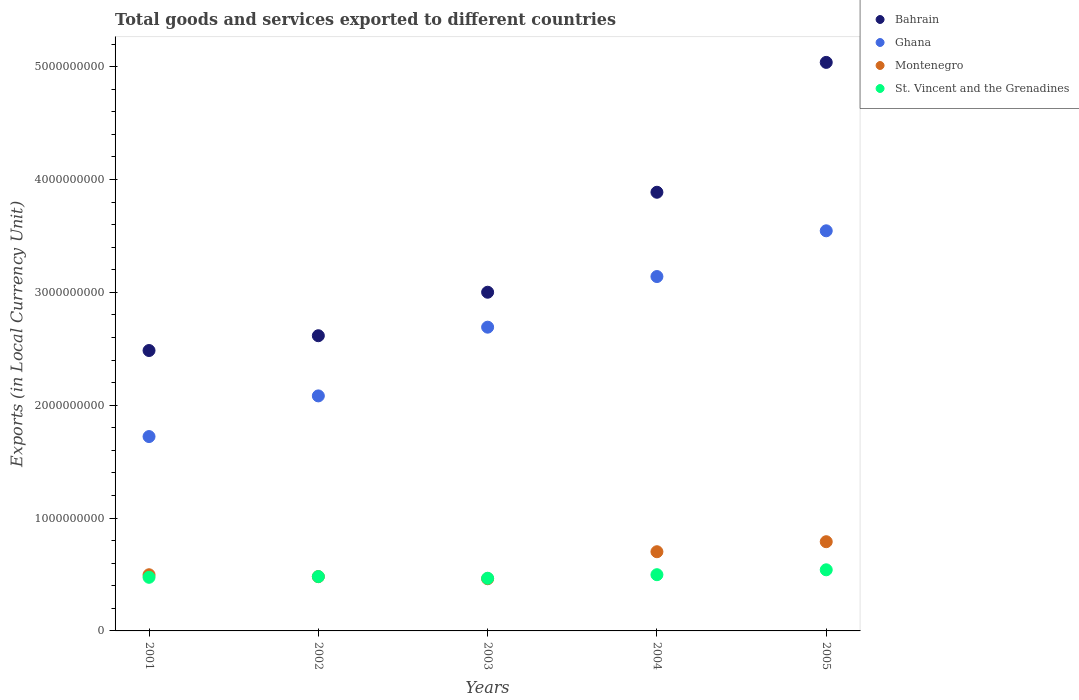Is the number of dotlines equal to the number of legend labels?
Offer a very short reply. Yes. What is the Amount of goods and services exports in St. Vincent and the Grenadines in 2004?
Make the answer very short. 4.98e+08. Across all years, what is the maximum Amount of goods and services exports in Ghana?
Your response must be concise. 3.55e+09. Across all years, what is the minimum Amount of goods and services exports in Ghana?
Keep it short and to the point. 1.72e+09. What is the total Amount of goods and services exports in Montenegro in the graph?
Keep it short and to the point. 2.93e+09. What is the difference between the Amount of goods and services exports in Ghana in 2001 and that in 2005?
Your answer should be compact. -1.82e+09. What is the difference between the Amount of goods and services exports in St. Vincent and the Grenadines in 2004 and the Amount of goods and services exports in Ghana in 2001?
Provide a short and direct response. -1.22e+09. What is the average Amount of goods and services exports in Bahrain per year?
Your answer should be very brief. 3.40e+09. In the year 2003, what is the difference between the Amount of goods and services exports in Bahrain and Amount of goods and services exports in Montenegro?
Your answer should be compact. 2.54e+09. What is the ratio of the Amount of goods and services exports in Bahrain in 2003 to that in 2005?
Make the answer very short. 0.6. Is the difference between the Amount of goods and services exports in Bahrain in 2002 and 2005 greater than the difference between the Amount of goods and services exports in Montenegro in 2002 and 2005?
Offer a terse response. No. What is the difference between the highest and the second highest Amount of goods and services exports in Ghana?
Give a very brief answer. 4.05e+08. What is the difference between the highest and the lowest Amount of goods and services exports in St. Vincent and the Grenadines?
Your answer should be compact. 7.48e+07. In how many years, is the Amount of goods and services exports in Montenegro greater than the average Amount of goods and services exports in Montenegro taken over all years?
Provide a short and direct response. 2. Does the Amount of goods and services exports in Montenegro monotonically increase over the years?
Give a very brief answer. No. What is the difference between two consecutive major ticks on the Y-axis?
Keep it short and to the point. 1.00e+09. Are the values on the major ticks of Y-axis written in scientific E-notation?
Give a very brief answer. No. Does the graph contain grids?
Your answer should be compact. No. Where does the legend appear in the graph?
Your answer should be very brief. Top right. How many legend labels are there?
Your answer should be compact. 4. How are the legend labels stacked?
Your answer should be very brief. Vertical. What is the title of the graph?
Provide a succinct answer. Total goods and services exported to different countries. Does "Tonga" appear as one of the legend labels in the graph?
Provide a succinct answer. No. What is the label or title of the X-axis?
Offer a terse response. Years. What is the label or title of the Y-axis?
Provide a short and direct response. Exports (in Local Currency Unit). What is the Exports (in Local Currency Unit) of Bahrain in 2001?
Keep it short and to the point. 2.48e+09. What is the Exports (in Local Currency Unit) of Ghana in 2001?
Offer a terse response. 1.72e+09. What is the Exports (in Local Currency Unit) in Montenegro in 2001?
Offer a terse response. 4.98e+08. What is the Exports (in Local Currency Unit) in St. Vincent and the Grenadines in 2001?
Offer a terse response. 4.75e+08. What is the Exports (in Local Currency Unit) of Bahrain in 2002?
Your response must be concise. 2.62e+09. What is the Exports (in Local Currency Unit) in Ghana in 2002?
Your response must be concise. 2.08e+09. What is the Exports (in Local Currency Unit) in Montenegro in 2002?
Your answer should be very brief. 4.81e+08. What is the Exports (in Local Currency Unit) of St. Vincent and the Grenadines in 2002?
Keep it short and to the point. 4.81e+08. What is the Exports (in Local Currency Unit) of Bahrain in 2003?
Your answer should be very brief. 3.00e+09. What is the Exports (in Local Currency Unit) in Ghana in 2003?
Your answer should be compact. 2.69e+09. What is the Exports (in Local Currency Unit) of Montenegro in 2003?
Offer a very short reply. 4.62e+08. What is the Exports (in Local Currency Unit) of St. Vincent and the Grenadines in 2003?
Your answer should be compact. 4.67e+08. What is the Exports (in Local Currency Unit) of Bahrain in 2004?
Keep it short and to the point. 3.89e+09. What is the Exports (in Local Currency Unit) in Ghana in 2004?
Offer a very short reply. 3.14e+09. What is the Exports (in Local Currency Unit) in Montenegro in 2004?
Offer a terse response. 7.02e+08. What is the Exports (in Local Currency Unit) of St. Vincent and the Grenadines in 2004?
Offer a terse response. 4.98e+08. What is the Exports (in Local Currency Unit) in Bahrain in 2005?
Your answer should be very brief. 5.04e+09. What is the Exports (in Local Currency Unit) in Ghana in 2005?
Offer a very short reply. 3.55e+09. What is the Exports (in Local Currency Unit) in Montenegro in 2005?
Keep it short and to the point. 7.90e+08. What is the Exports (in Local Currency Unit) of St. Vincent and the Grenadines in 2005?
Ensure brevity in your answer.  5.41e+08. Across all years, what is the maximum Exports (in Local Currency Unit) of Bahrain?
Give a very brief answer. 5.04e+09. Across all years, what is the maximum Exports (in Local Currency Unit) in Ghana?
Provide a succinct answer. 3.55e+09. Across all years, what is the maximum Exports (in Local Currency Unit) of Montenegro?
Offer a terse response. 7.90e+08. Across all years, what is the maximum Exports (in Local Currency Unit) in St. Vincent and the Grenadines?
Ensure brevity in your answer.  5.41e+08. Across all years, what is the minimum Exports (in Local Currency Unit) of Bahrain?
Offer a terse response. 2.48e+09. Across all years, what is the minimum Exports (in Local Currency Unit) of Ghana?
Make the answer very short. 1.72e+09. Across all years, what is the minimum Exports (in Local Currency Unit) in Montenegro?
Ensure brevity in your answer.  4.62e+08. Across all years, what is the minimum Exports (in Local Currency Unit) of St. Vincent and the Grenadines?
Make the answer very short. 4.67e+08. What is the total Exports (in Local Currency Unit) of Bahrain in the graph?
Ensure brevity in your answer.  1.70e+1. What is the total Exports (in Local Currency Unit) in Ghana in the graph?
Provide a short and direct response. 1.32e+1. What is the total Exports (in Local Currency Unit) in Montenegro in the graph?
Your answer should be very brief. 2.93e+09. What is the total Exports (in Local Currency Unit) in St. Vincent and the Grenadines in the graph?
Make the answer very short. 2.46e+09. What is the difference between the Exports (in Local Currency Unit) of Bahrain in 2001 and that in 2002?
Provide a short and direct response. -1.31e+08. What is the difference between the Exports (in Local Currency Unit) in Ghana in 2001 and that in 2002?
Give a very brief answer. -3.60e+08. What is the difference between the Exports (in Local Currency Unit) of Montenegro in 2001 and that in 2002?
Your answer should be compact. 1.67e+07. What is the difference between the Exports (in Local Currency Unit) in St. Vincent and the Grenadines in 2001 and that in 2002?
Provide a succinct answer. -6.40e+06. What is the difference between the Exports (in Local Currency Unit) in Bahrain in 2001 and that in 2003?
Offer a very short reply. -5.16e+08. What is the difference between the Exports (in Local Currency Unit) in Ghana in 2001 and that in 2003?
Ensure brevity in your answer.  -9.69e+08. What is the difference between the Exports (in Local Currency Unit) in Montenegro in 2001 and that in 2003?
Make the answer very short. 3.54e+07. What is the difference between the Exports (in Local Currency Unit) in St. Vincent and the Grenadines in 2001 and that in 2003?
Provide a succinct answer. 8.35e+06. What is the difference between the Exports (in Local Currency Unit) in Bahrain in 2001 and that in 2004?
Your answer should be compact. -1.40e+09. What is the difference between the Exports (in Local Currency Unit) of Ghana in 2001 and that in 2004?
Your response must be concise. -1.42e+09. What is the difference between the Exports (in Local Currency Unit) in Montenegro in 2001 and that in 2004?
Provide a short and direct response. -2.04e+08. What is the difference between the Exports (in Local Currency Unit) in St. Vincent and the Grenadines in 2001 and that in 2004?
Your response must be concise. -2.32e+07. What is the difference between the Exports (in Local Currency Unit) of Bahrain in 2001 and that in 2005?
Ensure brevity in your answer.  -2.55e+09. What is the difference between the Exports (in Local Currency Unit) of Ghana in 2001 and that in 2005?
Your answer should be compact. -1.82e+09. What is the difference between the Exports (in Local Currency Unit) in Montenegro in 2001 and that in 2005?
Provide a short and direct response. -2.93e+08. What is the difference between the Exports (in Local Currency Unit) of St. Vincent and the Grenadines in 2001 and that in 2005?
Ensure brevity in your answer.  -6.64e+07. What is the difference between the Exports (in Local Currency Unit) in Bahrain in 2002 and that in 2003?
Your answer should be very brief. -3.85e+08. What is the difference between the Exports (in Local Currency Unit) in Ghana in 2002 and that in 2003?
Provide a short and direct response. -6.09e+08. What is the difference between the Exports (in Local Currency Unit) in Montenegro in 2002 and that in 2003?
Give a very brief answer. 1.87e+07. What is the difference between the Exports (in Local Currency Unit) of St. Vincent and the Grenadines in 2002 and that in 2003?
Make the answer very short. 1.48e+07. What is the difference between the Exports (in Local Currency Unit) in Bahrain in 2002 and that in 2004?
Keep it short and to the point. -1.27e+09. What is the difference between the Exports (in Local Currency Unit) of Ghana in 2002 and that in 2004?
Make the answer very short. -1.06e+09. What is the difference between the Exports (in Local Currency Unit) in Montenegro in 2002 and that in 2004?
Offer a terse response. -2.21e+08. What is the difference between the Exports (in Local Currency Unit) of St. Vincent and the Grenadines in 2002 and that in 2004?
Keep it short and to the point. -1.68e+07. What is the difference between the Exports (in Local Currency Unit) of Bahrain in 2002 and that in 2005?
Your answer should be very brief. -2.42e+09. What is the difference between the Exports (in Local Currency Unit) of Ghana in 2002 and that in 2005?
Give a very brief answer. -1.46e+09. What is the difference between the Exports (in Local Currency Unit) in Montenegro in 2002 and that in 2005?
Ensure brevity in your answer.  -3.09e+08. What is the difference between the Exports (in Local Currency Unit) of St. Vincent and the Grenadines in 2002 and that in 2005?
Make the answer very short. -6.00e+07. What is the difference between the Exports (in Local Currency Unit) of Bahrain in 2003 and that in 2004?
Provide a succinct answer. -8.86e+08. What is the difference between the Exports (in Local Currency Unit) in Ghana in 2003 and that in 2004?
Your response must be concise. -4.49e+08. What is the difference between the Exports (in Local Currency Unit) in Montenegro in 2003 and that in 2004?
Make the answer very short. -2.39e+08. What is the difference between the Exports (in Local Currency Unit) in St. Vincent and the Grenadines in 2003 and that in 2004?
Your response must be concise. -3.15e+07. What is the difference between the Exports (in Local Currency Unit) of Bahrain in 2003 and that in 2005?
Offer a very short reply. -2.04e+09. What is the difference between the Exports (in Local Currency Unit) in Ghana in 2003 and that in 2005?
Your response must be concise. -8.54e+08. What is the difference between the Exports (in Local Currency Unit) in Montenegro in 2003 and that in 2005?
Your response must be concise. -3.28e+08. What is the difference between the Exports (in Local Currency Unit) of St. Vincent and the Grenadines in 2003 and that in 2005?
Give a very brief answer. -7.48e+07. What is the difference between the Exports (in Local Currency Unit) in Bahrain in 2004 and that in 2005?
Give a very brief answer. -1.15e+09. What is the difference between the Exports (in Local Currency Unit) of Ghana in 2004 and that in 2005?
Offer a terse response. -4.05e+08. What is the difference between the Exports (in Local Currency Unit) in Montenegro in 2004 and that in 2005?
Keep it short and to the point. -8.87e+07. What is the difference between the Exports (in Local Currency Unit) of St. Vincent and the Grenadines in 2004 and that in 2005?
Give a very brief answer. -4.33e+07. What is the difference between the Exports (in Local Currency Unit) of Bahrain in 2001 and the Exports (in Local Currency Unit) of Ghana in 2002?
Your response must be concise. 4.02e+08. What is the difference between the Exports (in Local Currency Unit) of Bahrain in 2001 and the Exports (in Local Currency Unit) of Montenegro in 2002?
Provide a short and direct response. 2.00e+09. What is the difference between the Exports (in Local Currency Unit) in Bahrain in 2001 and the Exports (in Local Currency Unit) in St. Vincent and the Grenadines in 2002?
Make the answer very short. 2.00e+09. What is the difference between the Exports (in Local Currency Unit) in Ghana in 2001 and the Exports (in Local Currency Unit) in Montenegro in 2002?
Offer a very short reply. 1.24e+09. What is the difference between the Exports (in Local Currency Unit) of Ghana in 2001 and the Exports (in Local Currency Unit) of St. Vincent and the Grenadines in 2002?
Provide a succinct answer. 1.24e+09. What is the difference between the Exports (in Local Currency Unit) of Montenegro in 2001 and the Exports (in Local Currency Unit) of St. Vincent and the Grenadines in 2002?
Keep it short and to the point. 1.62e+07. What is the difference between the Exports (in Local Currency Unit) of Bahrain in 2001 and the Exports (in Local Currency Unit) of Ghana in 2003?
Offer a terse response. -2.07e+08. What is the difference between the Exports (in Local Currency Unit) of Bahrain in 2001 and the Exports (in Local Currency Unit) of Montenegro in 2003?
Make the answer very short. 2.02e+09. What is the difference between the Exports (in Local Currency Unit) of Bahrain in 2001 and the Exports (in Local Currency Unit) of St. Vincent and the Grenadines in 2003?
Make the answer very short. 2.02e+09. What is the difference between the Exports (in Local Currency Unit) in Ghana in 2001 and the Exports (in Local Currency Unit) in Montenegro in 2003?
Provide a short and direct response. 1.26e+09. What is the difference between the Exports (in Local Currency Unit) of Ghana in 2001 and the Exports (in Local Currency Unit) of St. Vincent and the Grenadines in 2003?
Make the answer very short. 1.26e+09. What is the difference between the Exports (in Local Currency Unit) of Montenegro in 2001 and the Exports (in Local Currency Unit) of St. Vincent and the Grenadines in 2003?
Make the answer very short. 3.09e+07. What is the difference between the Exports (in Local Currency Unit) of Bahrain in 2001 and the Exports (in Local Currency Unit) of Ghana in 2004?
Offer a very short reply. -6.55e+08. What is the difference between the Exports (in Local Currency Unit) of Bahrain in 2001 and the Exports (in Local Currency Unit) of Montenegro in 2004?
Offer a terse response. 1.78e+09. What is the difference between the Exports (in Local Currency Unit) in Bahrain in 2001 and the Exports (in Local Currency Unit) in St. Vincent and the Grenadines in 2004?
Your response must be concise. 1.99e+09. What is the difference between the Exports (in Local Currency Unit) of Ghana in 2001 and the Exports (in Local Currency Unit) of Montenegro in 2004?
Give a very brief answer. 1.02e+09. What is the difference between the Exports (in Local Currency Unit) in Ghana in 2001 and the Exports (in Local Currency Unit) in St. Vincent and the Grenadines in 2004?
Give a very brief answer. 1.22e+09. What is the difference between the Exports (in Local Currency Unit) in Montenegro in 2001 and the Exports (in Local Currency Unit) in St. Vincent and the Grenadines in 2004?
Provide a short and direct response. -5.73e+05. What is the difference between the Exports (in Local Currency Unit) of Bahrain in 2001 and the Exports (in Local Currency Unit) of Ghana in 2005?
Provide a short and direct response. -1.06e+09. What is the difference between the Exports (in Local Currency Unit) of Bahrain in 2001 and the Exports (in Local Currency Unit) of Montenegro in 2005?
Give a very brief answer. 1.69e+09. What is the difference between the Exports (in Local Currency Unit) in Bahrain in 2001 and the Exports (in Local Currency Unit) in St. Vincent and the Grenadines in 2005?
Offer a terse response. 1.94e+09. What is the difference between the Exports (in Local Currency Unit) of Ghana in 2001 and the Exports (in Local Currency Unit) of Montenegro in 2005?
Provide a short and direct response. 9.32e+08. What is the difference between the Exports (in Local Currency Unit) in Ghana in 2001 and the Exports (in Local Currency Unit) in St. Vincent and the Grenadines in 2005?
Your answer should be very brief. 1.18e+09. What is the difference between the Exports (in Local Currency Unit) of Montenegro in 2001 and the Exports (in Local Currency Unit) of St. Vincent and the Grenadines in 2005?
Your answer should be compact. -4.38e+07. What is the difference between the Exports (in Local Currency Unit) of Bahrain in 2002 and the Exports (in Local Currency Unit) of Ghana in 2003?
Give a very brief answer. -7.57e+07. What is the difference between the Exports (in Local Currency Unit) in Bahrain in 2002 and the Exports (in Local Currency Unit) in Montenegro in 2003?
Provide a succinct answer. 2.15e+09. What is the difference between the Exports (in Local Currency Unit) of Bahrain in 2002 and the Exports (in Local Currency Unit) of St. Vincent and the Grenadines in 2003?
Ensure brevity in your answer.  2.15e+09. What is the difference between the Exports (in Local Currency Unit) of Ghana in 2002 and the Exports (in Local Currency Unit) of Montenegro in 2003?
Offer a terse response. 1.62e+09. What is the difference between the Exports (in Local Currency Unit) of Ghana in 2002 and the Exports (in Local Currency Unit) of St. Vincent and the Grenadines in 2003?
Offer a very short reply. 1.62e+09. What is the difference between the Exports (in Local Currency Unit) in Montenegro in 2002 and the Exports (in Local Currency Unit) in St. Vincent and the Grenadines in 2003?
Your answer should be compact. 1.43e+07. What is the difference between the Exports (in Local Currency Unit) of Bahrain in 2002 and the Exports (in Local Currency Unit) of Ghana in 2004?
Offer a very short reply. -5.24e+08. What is the difference between the Exports (in Local Currency Unit) in Bahrain in 2002 and the Exports (in Local Currency Unit) in Montenegro in 2004?
Offer a terse response. 1.91e+09. What is the difference between the Exports (in Local Currency Unit) in Bahrain in 2002 and the Exports (in Local Currency Unit) in St. Vincent and the Grenadines in 2004?
Provide a short and direct response. 2.12e+09. What is the difference between the Exports (in Local Currency Unit) in Ghana in 2002 and the Exports (in Local Currency Unit) in Montenegro in 2004?
Your answer should be compact. 1.38e+09. What is the difference between the Exports (in Local Currency Unit) of Ghana in 2002 and the Exports (in Local Currency Unit) of St. Vincent and the Grenadines in 2004?
Ensure brevity in your answer.  1.58e+09. What is the difference between the Exports (in Local Currency Unit) in Montenegro in 2002 and the Exports (in Local Currency Unit) in St. Vincent and the Grenadines in 2004?
Ensure brevity in your answer.  -1.72e+07. What is the difference between the Exports (in Local Currency Unit) of Bahrain in 2002 and the Exports (in Local Currency Unit) of Ghana in 2005?
Ensure brevity in your answer.  -9.30e+08. What is the difference between the Exports (in Local Currency Unit) of Bahrain in 2002 and the Exports (in Local Currency Unit) of Montenegro in 2005?
Your answer should be compact. 1.83e+09. What is the difference between the Exports (in Local Currency Unit) in Bahrain in 2002 and the Exports (in Local Currency Unit) in St. Vincent and the Grenadines in 2005?
Make the answer very short. 2.07e+09. What is the difference between the Exports (in Local Currency Unit) of Ghana in 2002 and the Exports (in Local Currency Unit) of Montenegro in 2005?
Keep it short and to the point. 1.29e+09. What is the difference between the Exports (in Local Currency Unit) of Ghana in 2002 and the Exports (in Local Currency Unit) of St. Vincent and the Grenadines in 2005?
Offer a very short reply. 1.54e+09. What is the difference between the Exports (in Local Currency Unit) in Montenegro in 2002 and the Exports (in Local Currency Unit) in St. Vincent and the Grenadines in 2005?
Make the answer very short. -6.05e+07. What is the difference between the Exports (in Local Currency Unit) in Bahrain in 2003 and the Exports (in Local Currency Unit) in Ghana in 2004?
Offer a terse response. -1.39e+08. What is the difference between the Exports (in Local Currency Unit) of Bahrain in 2003 and the Exports (in Local Currency Unit) of Montenegro in 2004?
Your answer should be very brief. 2.30e+09. What is the difference between the Exports (in Local Currency Unit) of Bahrain in 2003 and the Exports (in Local Currency Unit) of St. Vincent and the Grenadines in 2004?
Your response must be concise. 2.50e+09. What is the difference between the Exports (in Local Currency Unit) in Ghana in 2003 and the Exports (in Local Currency Unit) in Montenegro in 2004?
Ensure brevity in your answer.  1.99e+09. What is the difference between the Exports (in Local Currency Unit) of Ghana in 2003 and the Exports (in Local Currency Unit) of St. Vincent and the Grenadines in 2004?
Provide a short and direct response. 2.19e+09. What is the difference between the Exports (in Local Currency Unit) in Montenegro in 2003 and the Exports (in Local Currency Unit) in St. Vincent and the Grenadines in 2004?
Offer a very short reply. -3.59e+07. What is the difference between the Exports (in Local Currency Unit) of Bahrain in 2003 and the Exports (in Local Currency Unit) of Ghana in 2005?
Keep it short and to the point. -5.44e+08. What is the difference between the Exports (in Local Currency Unit) of Bahrain in 2003 and the Exports (in Local Currency Unit) of Montenegro in 2005?
Keep it short and to the point. 2.21e+09. What is the difference between the Exports (in Local Currency Unit) in Bahrain in 2003 and the Exports (in Local Currency Unit) in St. Vincent and the Grenadines in 2005?
Make the answer very short. 2.46e+09. What is the difference between the Exports (in Local Currency Unit) in Ghana in 2003 and the Exports (in Local Currency Unit) in Montenegro in 2005?
Make the answer very short. 1.90e+09. What is the difference between the Exports (in Local Currency Unit) in Ghana in 2003 and the Exports (in Local Currency Unit) in St. Vincent and the Grenadines in 2005?
Your response must be concise. 2.15e+09. What is the difference between the Exports (in Local Currency Unit) of Montenegro in 2003 and the Exports (in Local Currency Unit) of St. Vincent and the Grenadines in 2005?
Keep it short and to the point. -7.92e+07. What is the difference between the Exports (in Local Currency Unit) of Bahrain in 2004 and the Exports (in Local Currency Unit) of Ghana in 2005?
Your answer should be compact. 3.42e+08. What is the difference between the Exports (in Local Currency Unit) in Bahrain in 2004 and the Exports (in Local Currency Unit) in Montenegro in 2005?
Offer a terse response. 3.10e+09. What is the difference between the Exports (in Local Currency Unit) of Bahrain in 2004 and the Exports (in Local Currency Unit) of St. Vincent and the Grenadines in 2005?
Give a very brief answer. 3.35e+09. What is the difference between the Exports (in Local Currency Unit) of Ghana in 2004 and the Exports (in Local Currency Unit) of Montenegro in 2005?
Offer a terse response. 2.35e+09. What is the difference between the Exports (in Local Currency Unit) of Ghana in 2004 and the Exports (in Local Currency Unit) of St. Vincent and the Grenadines in 2005?
Your answer should be compact. 2.60e+09. What is the difference between the Exports (in Local Currency Unit) in Montenegro in 2004 and the Exports (in Local Currency Unit) in St. Vincent and the Grenadines in 2005?
Give a very brief answer. 1.60e+08. What is the average Exports (in Local Currency Unit) in Bahrain per year?
Keep it short and to the point. 3.40e+09. What is the average Exports (in Local Currency Unit) in Ghana per year?
Make the answer very short. 2.64e+09. What is the average Exports (in Local Currency Unit) in Montenegro per year?
Offer a terse response. 5.87e+08. What is the average Exports (in Local Currency Unit) of St. Vincent and the Grenadines per year?
Offer a terse response. 4.93e+08. In the year 2001, what is the difference between the Exports (in Local Currency Unit) in Bahrain and Exports (in Local Currency Unit) in Ghana?
Provide a succinct answer. 7.62e+08. In the year 2001, what is the difference between the Exports (in Local Currency Unit) of Bahrain and Exports (in Local Currency Unit) of Montenegro?
Your answer should be compact. 1.99e+09. In the year 2001, what is the difference between the Exports (in Local Currency Unit) of Bahrain and Exports (in Local Currency Unit) of St. Vincent and the Grenadines?
Provide a short and direct response. 2.01e+09. In the year 2001, what is the difference between the Exports (in Local Currency Unit) of Ghana and Exports (in Local Currency Unit) of Montenegro?
Offer a terse response. 1.22e+09. In the year 2001, what is the difference between the Exports (in Local Currency Unit) in Ghana and Exports (in Local Currency Unit) in St. Vincent and the Grenadines?
Offer a very short reply. 1.25e+09. In the year 2001, what is the difference between the Exports (in Local Currency Unit) in Montenegro and Exports (in Local Currency Unit) in St. Vincent and the Grenadines?
Make the answer very short. 2.26e+07. In the year 2002, what is the difference between the Exports (in Local Currency Unit) of Bahrain and Exports (in Local Currency Unit) of Ghana?
Offer a terse response. 5.33e+08. In the year 2002, what is the difference between the Exports (in Local Currency Unit) in Bahrain and Exports (in Local Currency Unit) in Montenegro?
Offer a terse response. 2.13e+09. In the year 2002, what is the difference between the Exports (in Local Currency Unit) of Bahrain and Exports (in Local Currency Unit) of St. Vincent and the Grenadines?
Give a very brief answer. 2.13e+09. In the year 2002, what is the difference between the Exports (in Local Currency Unit) in Ghana and Exports (in Local Currency Unit) in Montenegro?
Provide a succinct answer. 1.60e+09. In the year 2002, what is the difference between the Exports (in Local Currency Unit) in Ghana and Exports (in Local Currency Unit) in St. Vincent and the Grenadines?
Your answer should be very brief. 1.60e+09. In the year 2002, what is the difference between the Exports (in Local Currency Unit) of Montenegro and Exports (in Local Currency Unit) of St. Vincent and the Grenadines?
Ensure brevity in your answer.  -4.77e+05. In the year 2003, what is the difference between the Exports (in Local Currency Unit) of Bahrain and Exports (in Local Currency Unit) of Ghana?
Offer a very short reply. 3.10e+08. In the year 2003, what is the difference between the Exports (in Local Currency Unit) of Bahrain and Exports (in Local Currency Unit) of Montenegro?
Give a very brief answer. 2.54e+09. In the year 2003, what is the difference between the Exports (in Local Currency Unit) in Bahrain and Exports (in Local Currency Unit) in St. Vincent and the Grenadines?
Provide a short and direct response. 2.53e+09. In the year 2003, what is the difference between the Exports (in Local Currency Unit) in Ghana and Exports (in Local Currency Unit) in Montenegro?
Offer a terse response. 2.23e+09. In the year 2003, what is the difference between the Exports (in Local Currency Unit) of Ghana and Exports (in Local Currency Unit) of St. Vincent and the Grenadines?
Provide a succinct answer. 2.22e+09. In the year 2003, what is the difference between the Exports (in Local Currency Unit) of Montenegro and Exports (in Local Currency Unit) of St. Vincent and the Grenadines?
Keep it short and to the point. -4.42e+06. In the year 2004, what is the difference between the Exports (in Local Currency Unit) in Bahrain and Exports (in Local Currency Unit) in Ghana?
Offer a terse response. 7.47e+08. In the year 2004, what is the difference between the Exports (in Local Currency Unit) in Bahrain and Exports (in Local Currency Unit) in Montenegro?
Keep it short and to the point. 3.18e+09. In the year 2004, what is the difference between the Exports (in Local Currency Unit) of Bahrain and Exports (in Local Currency Unit) of St. Vincent and the Grenadines?
Your answer should be very brief. 3.39e+09. In the year 2004, what is the difference between the Exports (in Local Currency Unit) in Ghana and Exports (in Local Currency Unit) in Montenegro?
Provide a succinct answer. 2.44e+09. In the year 2004, what is the difference between the Exports (in Local Currency Unit) of Ghana and Exports (in Local Currency Unit) of St. Vincent and the Grenadines?
Your response must be concise. 2.64e+09. In the year 2004, what is the difference between the Exports (in Local Currency Unit) in Montenegro and Exports (in Local Currency Unit) in St. Vincent and the Grenadines?
Your answer should be very brief. 2.03e+08. In the year 2005, what is the difference between the Exports (in Local Currency Unit) in Bahrain and Exports (in Local Currency Unit) in Ghana?
Offer a very short reply. 1.49e+09. In the year 2005, what is the difference between the Exports (in Local Currency Unit) of Bahrain and Exports (in Local Currency Unit) of Montenegro?
Give a very brief answer. 4.25e+09. In the year 2005, what is the difference between the Exports (in Local Currency Unit) of Bahrain and Exports (in Local Currency Unit) of St. Vincent and the Grenadines?
Your answer should be very brief. 4.50e+09. In the year 2005, what is the difference between the Exports (in Local Currency Unit) of Ghana and Exports (in Local Currency Unit) of Montenegro?
Give a very brief answer. 2.75e+09. In the year 2005, what is the difference between the Exports (in Local Currency Unit) in Ghana and Exports (in Local Currency Unit) in St. Vincent and the Grenadines?
Ensure brevity in your answer.  3.00e+09. In the year 2005, what is the difference between the Exports (in Local Currency Unit) of Montenegro and Exports (in Local Currency Unit) of St. Vincent and the Grenadines?
Your response must be concise. 2.49e+08. What is the ratio of the Exports (in Local Currency Unit) in Bahrain in 2001 to that in 2002?
Ensure brevity in your answer.  0.95. What is the ratio of the Exports (in Local Currency Unit) of Ghana in 2001 to that in 2002?
Offer a very short reply. 0.83. What is the ratio of the Exports (in Local Currency Unit) of Montenegro in 2001 to that in 2002?
Offer a very short reply. 1.03. What is the ratio of the Exports (in Local Currency Unit) in St. Vincent and the Grenadines in 2001 to that in 2002?
Give a very brief answer. 0.99. What is the ratio of the Exports (in Local Currency Unit) in Bahrain in 2001 to that in 2003?
Make the answer very short. 0.83. What is the ratio of the Exports (in Local Currency Unit) of Ghana in 2001 to that in 2003?
Your response must be concise. 0.64. What is the ratio of the Exports (in Local Currency Unit) of Montenegro in 2001 to that in 2003?
Your answer should be very brief. 1.08. What is the ratio of the Exports (in Local Currency Unit) in St. Vincent and the Grenadines in 2001 to that in 2003?
Your response must be concise. 1.02. What is the ratio of the Exports (in Local Currency Unit) of Bahrain in 2001 to that in 2004?
Give a very brief answer. 0.64. What is the ratio of the Exports (in Local Currency Unit) of Ghana in 2001 to that in 2004?
Provide a succinct answer. 0.55. What is the ratio of the Exports (in Local Currency Unit) of Montenegro in 2001 to that in 2004?
Offer a terse response. 0.71. What is the ratio of the Exports (in Local Currency Unit) in St. Vincent and the Grenadines in 2001 to that in 2004?
Provide a succinct answer. 0.95. What is the ratio of the Exports (in Local Currency Unit) in Bahrain in 2001 to that in 2005?
Offer a very short reply. 0.49. What is the ratio of the Exports (in Local Currency Unit) of Ghana in 2001 to that in 2005?
Ensure brevity in your answer.  0.49. What is the ratio of the Exports (in Local Currency Unit) in Montenegro in 2001 to that in 2005?
Give a very brief answer. 0.63. What is the ratio of the Exports (in Local Currency Unit) in St. Vincent and the Grenadines in 2001 to that in 2005?
Your response must be concise. 0.88. What is the ratio of the Exports (in Local Currency Unit) in Bahrain in 2002 to that in 2003?
Keep it short and to the point. 0.87. What is the ratio of the Exports (in Local Currency Unit) of Ghana in 2002 to that in 2003?
Your answer should be very brief. 0.77. What is the ratio of the Exports (in Local Currency Unit) of Montenegro in 2002 to that in 2003?
Offer a terse response. 1.04. What is the ratio of the Exports (in Local Currency Unit) in St. Vincent and the Grenadines in 2002 to that in 2003?
Ensure brevity in your answer.  1.03. What is the ratio of the Exports (in Local Currency Unit) of Bahrain in 2002 to that in 2004?
Your answer should be compact. 0.67. What is the ratio of the Exports (in Local Currency Unit) in Ghana in 2002 to that in 2004?
Give a very brief answer. 0.66. What is the ratio of the Exports (in Local Currency Unit) in Montenegro in 2002 to that in 2004?
Your response must be concise. 0.69. What is the ratio of the Exports (in Local Currency Unit) of St. Vincent and the Grenadines in 2002 to that in 2004?
Ensure brevity in your answer.  0.97. What is the ratio of the Exports (in Local Currency Unit) of Bahrain in 2002 to that in 2005?
Offer a very short reply. 0.52. What is the ratio of the Exports (in Local Currency Unit) in Ghana in 2002 to that in 2005?
Ensure brevity in your answer.  0.59. What is the ratio of the Exports (in Local Currency Unit) in Montenegro in 2002 to that in 2005?
Your response must be concise. 0.61. What is the ratio of the Exports (in Local Currency Unit) of St. Vincent and the Grenadines in 2002 to that in 2005?
Offer a very short reply. 0.89. What is the ratio of the Exports (in Local Currency Unit) in Bahrain in 2003 to that in 2004?
Ensure brevity in your answer.  0.77. What is the ratio of the Exports (in Local Currency Unit) in Montenegro in 2003 to that in 2004?
Your response must be concise. 0.66. What is the ratio of the Exports (in Local Currency Unit) of St. Vincent and the Grenadines in 2003 to that in 2004?
Your response must be concise. 0.94. What is the ratio of the Exports (in Local Currency Unit) in Bahrain in 2003 to that in 2005?
Keep it short and to the point. 0.6. What is the ratio of the Exports (in Local Currency Unit) in Ghana in 2003 to that in 2005?
Offer a very short reply. 0.76. What is the ratio of the Exports (in Local Currency Unit) of Montenegro in 2003 to that in 2005?
Your answer should be very brief. 0.58. What is the ratio of the Exports (in Local Currency Unit) of St. Vincent and the Grenadines in 2003 to that in 2005?
Provide a short and direct response. 0.86. What is the ratio of the Exports (in Local Currency Unit) in Bahrain in 2004 to that in 2005?
Give a very brief answer. 0.77. What is the ratio of the Exports (in Local Currency Unit) of Ghana in 2004 to that in 2005?
Your answer should be compact. 0.89. What is the ratio of the Exports (in Local Currency Unit) in Montenegro in 2004 to that in 2005?
Ensure brevity in your answer.  0.89. What is the ratio of the Exports (in Local Currency Unit) of St. Vincent and the Grenadines in 2004 to that in 2005?
Keep it short and to the point. 0.92. What is the difference between the highest and the second highest Exports (in Local Currency Unit) in Bahrain?
Give a very brief answer. 1.15e+09. What is the difference between the highest and the second highest Exports (in Local Currency Unit) in Ghana?
Ensure brevity in your answer.  4.05e+08. What is the difference between the highest and the second highest Exports (in Local Currency Unit) of Montenegro?
Provide a short and direct response. 8.87e+07. What is the difference between the highest and the second highest Exports (in Local Currency Unit) in St. Vincent and the Grenadines?
Make the answer very short. 4.33e+07. What is the difference between the highest and the lowest Exports (in Local Currency Unit) of Bahrain?
Make the answer very short. 2.55e+09. What is the difference between the highest and the lowest Exports (in Local Currency Unit) of Ghana?
Your response must be concise. 1.82e+09. What is the difference between the highest and the lowest Exports (in Local Currency Unit) in Montenegro?
Provide a short and direct response. 3.28e+08. What is the difference between the highest and the lowest Exports (in Local Currency Unit) of St. Vincent and the Grenadines?
Give a very brief answer. 7.48e+07. 